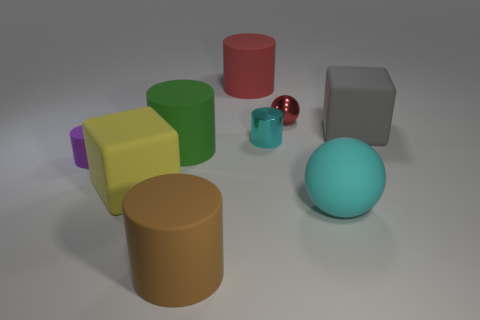Can you describe the relative sizes and colors of the objects in the image? Certainly! In the image, we see several geometric shapes varying in size and color. There is a large brown cylinder, a medium-sized green cube, a smaller yellow cuboid, and a tiny purple cube. Additionally, there is a small red cylinder, a smaller blue cylinder, a sphere with a light blue hue, and the smallest item appears to be a shiny red sphere that could be a marble. 